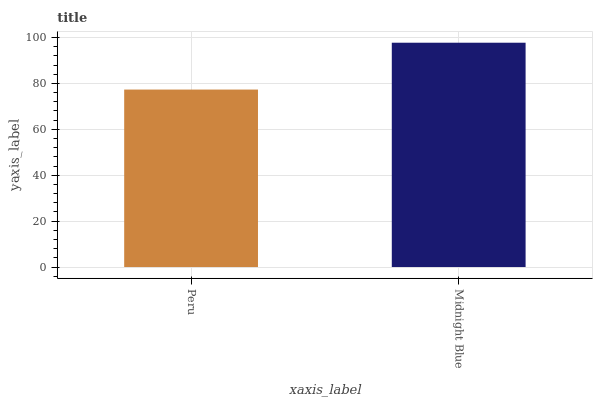Is Peru the minimum?
Answer yes or no. Yes. Is Midnight Blue the maximum?
Answer yes or no. Yes. Is Midnight Blue the minimum?
Answer yes or no. No. Is Midnight Blue greater than Peru?
Answer yes or no. Yes. Is Peru less than Midnight Blue?
Answer yes or no. Yes. Is Peru greater than Midnight Blue?
Answer yes or no. No. Is Midnight Blue less than Peru?
Answer yes or no. No. Is Midnight Blue the high median?
Answer yes or no. Yes. Is Peru the low median?
Answer yes or no. Yes. Is Peru the high median?
Answer yes or no. No. Is Midnight Blue the low median?
Answer yes or no. No. 